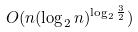<formula> <loc_0><loc_0><loc_500><loc_500>O ( n ( \log _ { 2 } n ) ^ { \log _ { 2 } \frac { 3 } { 2 } } )</formula> 